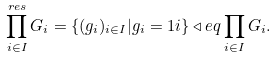Convert formula to latex. <formula><loc_0><loc_0><loc_500><loc_500>\prod _ { i \in I } ^ { r e s } G _ { i } = \{ ( g _ { i } ) _ { i \in I } | g _ { i } = 1 i \} \triangleleft e q \prod _ { i \in I } G _ { i } .</formula> 